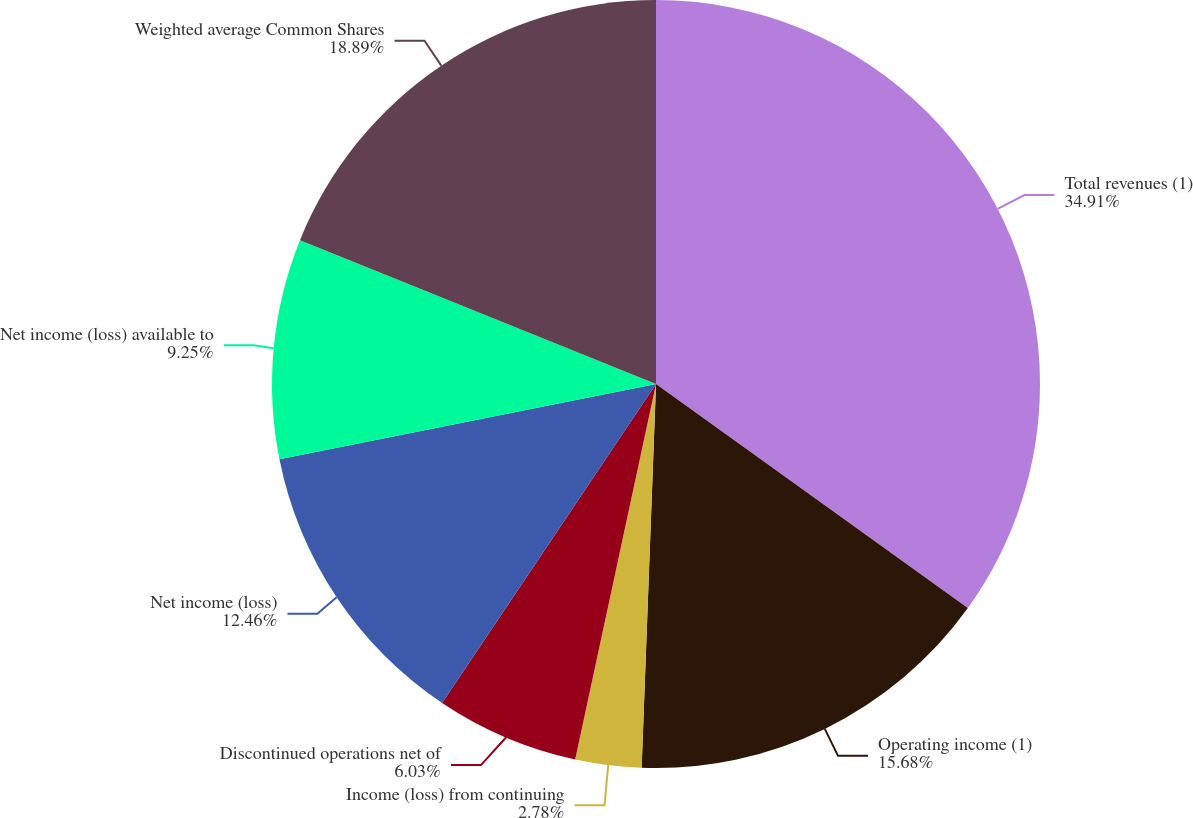Convert chart to OTSL. <chart><loc_0><loc_0><loc_500><loc_500><pie_chart><fcel>Total revenues (1)<fcel>Operating income (1)<fcel>Income (loss) from continuing<fcel>Discontinued operations net of<fcel>Net income (loss)<fcel>Net income (loss) available to<fcel>Weighted average Common Shares<nl><fcel>34.92%<fcel>15.68%<fcel>2.78%<fcel>6.03%<fcel>12.46%<fcel>9.25%<fcel>18.89%<nl></chart> 